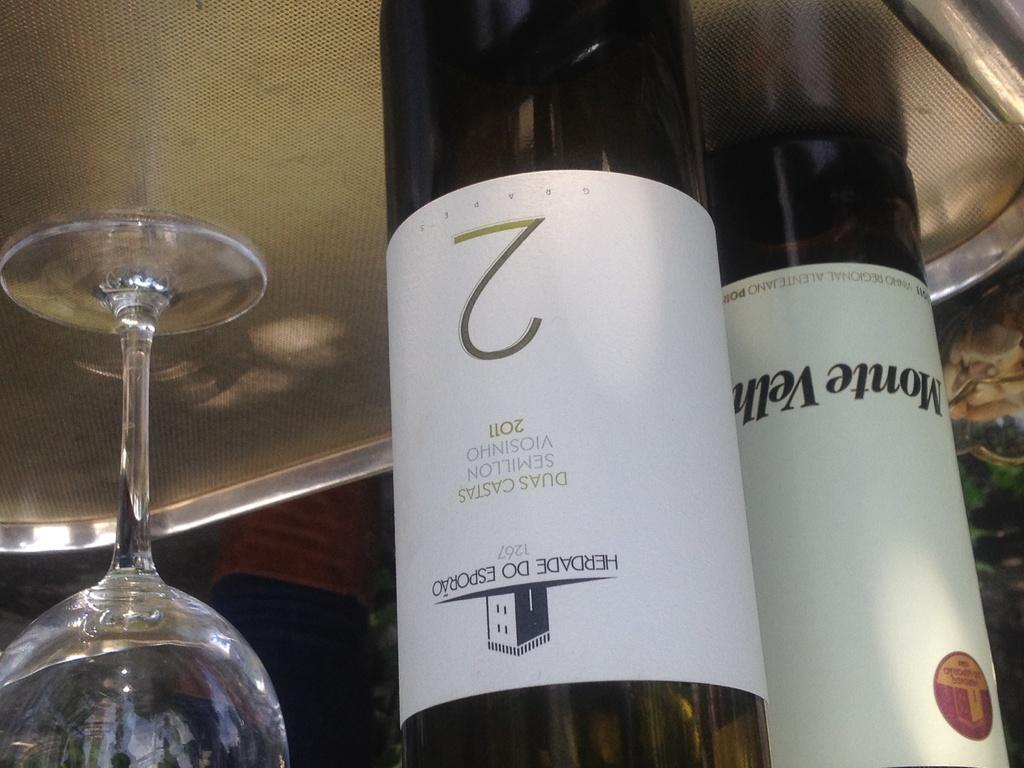<image>
Create a compact narrative representing the image presented. A bottole of Daus Castas and a bottle of Monte Velh sit on a tray with one glass 